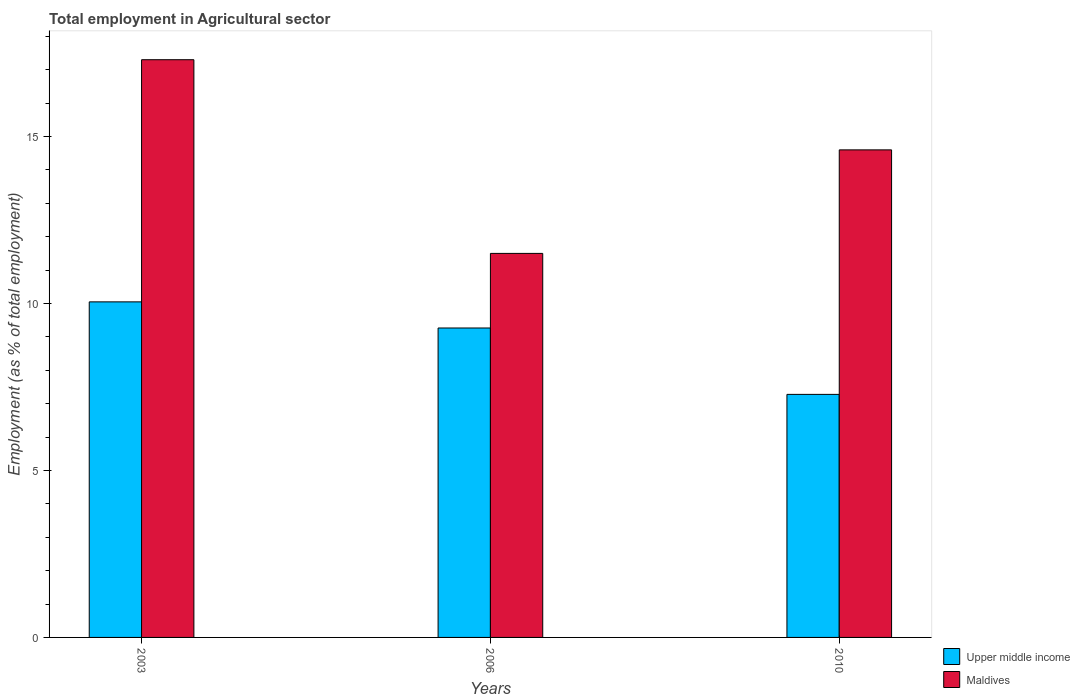How many different coloured bars are there?
Offer a terse response. 2. Are the number of bars on each tick of the X-axis equal?
Make the answer very short. Yes. What is the label of the 1st group of bars from the left?
Ensure brevity in your answer.  2003. What is the employment in agricultural sector in Upper middle income in 2010?
Offer a very short reply. 7.28. Across all years, what is the maximum employment in agricultural sector in Upper middle income?
Offer a terse response. 10.05. Across all years, what is the minimum employment in agricultural sector in Upper middle income?
Provide a short and direct response. 7.28. In which year was the employment in agricultural sector in Upper middle income minimum?
Offer a very short reply. 2010. What is the total employment in agricultural sector in Maldives in the graph?
Your answer should be compact. 43.4. What is the difference between the employment in agricultural sector in Maldives in 2003 and that in 2006?
Offer a terse response. 5.8. What is the difference between the employment in agricultural sector in Upper middle income in 2010 and the employment in agricultural sector in Maldives in 2003?
Provide a succinct answer. -10.02. What is the average employment in agricultural sector in Maldives per year?
Your response must be concise. 14.47. In the year 2006, what is the difference between the employment in agricultural sector in Upper middle income and employment in agricultural sector in Maldives?
Ensure brevity in your answer.  -2.23. In how many years, is the employment in agricultural sector in Maldives greater than 7 %?
Provide a short and direct response. 3. What is the ratio of the employment in agricultural sector in Maldives in 2003 to that in 2010?
Ensure brevity in your answer.  1.18. Is the employment in agricultural sector in Maldives in 2003 less than that in 2006?
Keep it short and to the point. No. Is the difference between the employment in agricultural sector in Upper middle income in 2003 and 2006 greater than the difference between the employment in agricultural sector in Maldives in 2003 and 2006?
Provide a succinct answer. No. What is the difference between the highest and the second highest employment in agricultural sector in Upper middle income?
Offer a very short reply. 0.78. What is the difference between the highest and the lowest employment in agricultural sector in Maldives?
Offer a terse response. 5.8. Is the sum of the employment in agricultural sector in Upper middle income in 2003 and 2006 greater than the maximum employment in agricultural sector in Maldives across all years?
Your response must be concise. Yes. What does the 1st bar from the left in 2010 represents?
Offer a very short reply. Upper middle income. What does the 1st bar from the right in 2006 represents?
Your response must be concise. Maldives. How many bars are there?
Offer a very short reply. 6. Are all the bars in the graph horizontal?
Make the answer very short. No. Are the values on the major ticks of Y-axis written in scientific E-notation?
Give a very brief answer. No. How many legend labels are there?
Provide a short and direct response. 2. How are the legend labels stacked?
Provide a short and direct response. Vertical. What is the title of the graph?
Provide a short and direct response. Total employment in Agricultural sector. What is the label or title of the X-axis?
Keep it short and to the point. Years. What is the label or title of the Y-axis?
Offer a terse response. Employment (as % of total employment). What is the Employment (as % of total employment) in Upper middle income in 2003?
Your answer should be very brief. 10.05. What is the Employment (as % of total employment) of Maldives in 2003?
Provide a succinct answer. 17.3. What is the Employment (as % of total employment) in Upper middle income in 2006?
Make the answer very short. 9.27. What is the Employment (as % of total employment) in Maldives in 2006?
Ensure brevity in your answer.  11.5. What is the Employment (as % of total employment) of Upper middle income in 2010?
Keep it short and to the point. 7.28. What is the Employment (as % of total employment) of Maldives in 2010?
Make the answer very short. 14.6. Across all years, what is the maximum Employment (as % of total employment) in Upper middle income?
Ensure brevity in your answer.  10.05. Across all years, what is the maximum Employment (as % of total employment) of Maldives?
Provide a succinct answer. 17.3. Across all years, what is the minimum Employment (as % of total employment) of Upper middle income?
Your response must be concise. 7.28. Across all years, what is the minimum Employment (as % of total employment) in Maldives?
Give a very brief answer. 11.5. What is the total Employment (as % of total employment) in Upper middle income in the graph?
Provide a short and direct response. 26.59. What is the total Employment (as % of total employment) in Maldives in the graph?
Offer a terse response. 43.4. What is the difference between the Employment (as % of total employment) of Upper middle income in 2003 and that in 2006?
Provide a short and direct response. 0.78. What is the difference between the Employment (as % of total employment) of Upper middle income in 2003 and that in 2010?
Make the answer very short. 2.77. What is the difference between the Employment (as % of total employment) in Maldives in 2003 and that in 2010?
Offer a terse response. 2.7. What is the difference between the Employment (as % of total employment) in Upper middle income in 2006 and that in 2010?
Ensure brevity in your answer.  1.99. What is the difference between the Employment (as % of total employment) of Maldives in 2006 and that in 2010?
Offer a terse response. -3.1. What is the difference between the Employment (as % of total employment) of Upper middle income in 2003 and the Employment (as % of total employment) of Maldives in 2006?
Make the answer very short. -1.45. What is the difference between the Employment (as % of total employment) in Upper middle income in 2003 and the Employment (as % of total employment) in Maldives in 2010?
Your answer should be very brief. -4.55. What is the difference between the Employment (as % of total employment) of Upper middle income in 2006 and the Employment (as % of total employment) of Maldives in 2010?
Your answer should be very brief. -5.33. What is the average Employment (as % of total employment) of Upper middle income per year?
Give a very brief answer. 8.86. What is the average Employment (as % of total employment) in Maldives per year?
Your answer should be very brief. 14.47. In the year 2003, what is the difference between the Employment (as % of total employment) in Upper middle income and Employment (as % of total employment) in Maldives?
Make the answer very short. -7.25. In the year 2006, what is the difference between the Employment (as % of total employment) in Upper middle income and Employment (as % of total employment) in Maldives?
Provide a succinct answer. -2.23. In the year 2010, what is the difference between the Employment (as % of total employment) in Upper middle income and Employment (as % of total employment) in Maldives?
Your answer should be compact. -7.32. What is the ratio of the Employment (as % of total employment) in Upper middle income in 2003 to that in 2006?
Make the answer very short. 1.08. What is the ratio of the Employment (as % of total employment) in Maldives in 2003 to that in 2006?
Your answer should be very brief. 1.5. What is the ratio of the Employment (as % of total employment) of Upper middle income in 2003 to that in 2010?
Offer a terse response. 1.38. What is the ratio of the Employment (as % of total employment) in Maldives in 2003 to that in 2010?
Give a very brief answer. 1.18. What is the ratio of the Employment (as % of total employment) of Upper middle income in 2006 to that in 2010?
Keep it short and to the point. 1.27. What is the ratio of the Employment (as % of total employment) of Maldives in 2006 to that in 2010?
Offer a very short reply. 0.79. What is the difference between the highest and the second highest Employment (as % of total employment) of Upper middle income?
Make the answer very short. 0.78. What is the difference between the highest and the lowest Employment (as % of total employment) of Upper middle income?
Your answer should be compact. 2.77. 